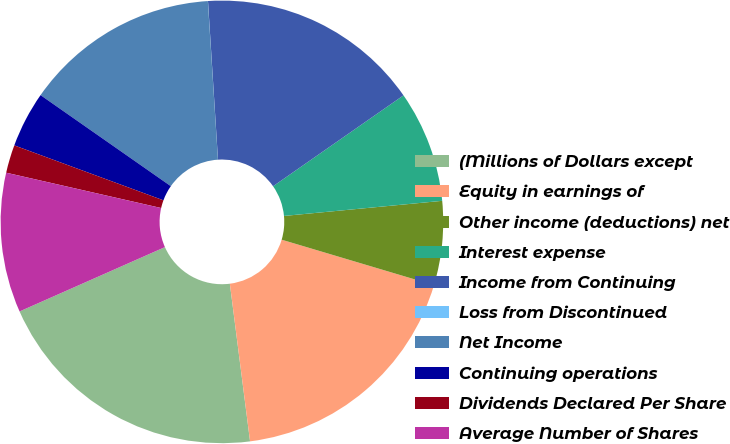Convert chart to OTSL. <chart><loc_0><loc_0><loc_500><loc_500><pie_chart><fcel>(Millions of Dollars except<fcel>Equity in earnings of<fcel>Other income (deductions) net<fcel>Interest expense<fcel>Income from Continuing<fcel>Loss from Discontinued<fcel>Net Income<fcel>Continuing operations<fcel>Dividends Declared Per Share<fcel>Average Number of Shares<nl><fcel>20.4%<fcel>18.36%<fcel>6.13%<fcel>8.17%<fcel>16.32%<fcel>0.01%<fcel>14.28%<fcel>4.09%<fcel>2.05%<fcel>10.2%<nl></chart> 